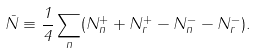<formula> <loc_0><loc_0><loc_500><loc_500>\bar { N } \equiv \frac { 1 } { 4 } \sum _ { n } ( N _ { n } ^ { + } + N _ { r } ^ { + } - N _ { n } ^ { - } - N _ { r } ^ { - } ) .</formula> 